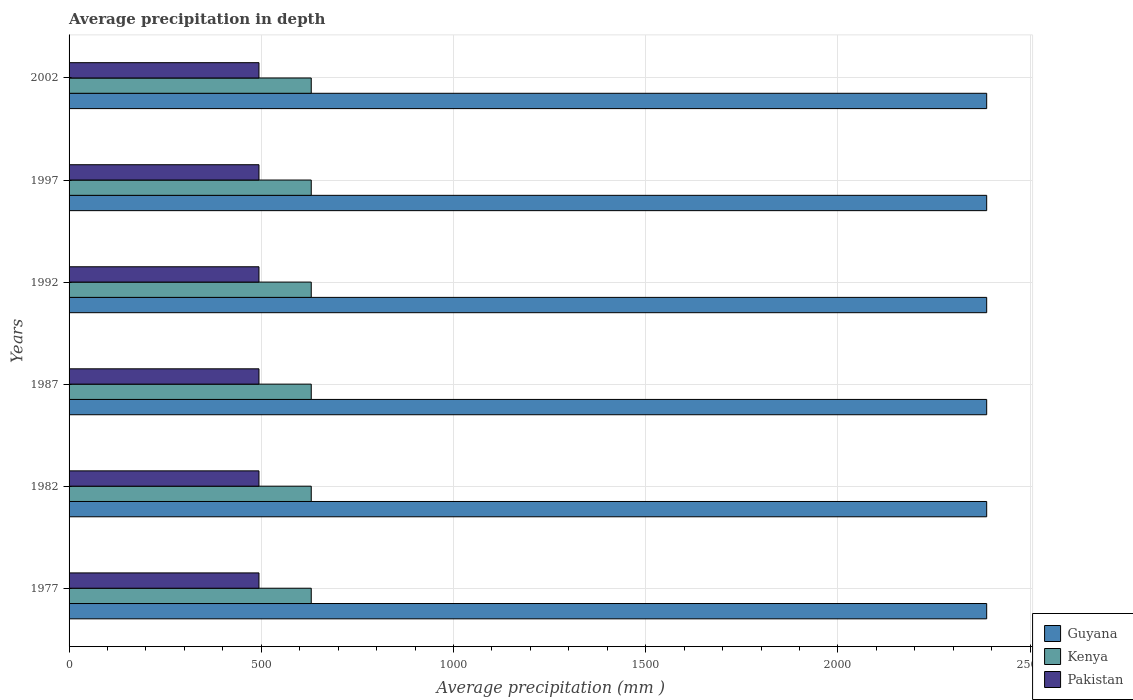How many different coloured bars are there?
Give a very brief answer. 3. What is the average precipitation in Kenya in 1992?
Your answer should be compact. 630. Across all years, what is the maximum average precipitation in Pakistan?
Ensure brevity in your answer.  494. Across all years, what is the minimum average precipitation in Guyana?
Offer a very short reply. 2387. In which year was the average precipitation in Kenya maximum?
Your answer should be compact. 1977. What is the total average precipitation in Guyana in the graph?
Provide a succinct answer. 1.43e+04. What is the difference between the average precipitation in Kenya in 1987 and the average precipitation in Guyana in 2002?
Make the answer very short. -1757. What is the average average precipitation in Kenya per year?
Your answer should be compact. 630. In the year 2002, what is the difference between the average precipitation in Kenya and average precipitation in Guyana?
Your answer should be compact. -1757. In how many years, is the average precipitation in Guyana greater than 1200 mm?
Keep it short and to the point. 6. Is the average precipitation in Kenya in 1987 less than that in 1997?
Your answer should be compact. No. Is the difference between the average precipitation in Kenya in 1982 and 1997 greater than the difference between the average precipitation in Guyana in 1982 and 1997?
Your answer should be very brief. No. Is the sum of the average precipitation in Kenya in 1977 and 2002 greater than the maximum average precipitation in Guyana across all years?
Provide a short and direct response. No. What does the 3rd bar from the bottom in 1997 represents?
Provide a succinct answer. Pakistan. What is the difference between two consecutive major ticks on the X-axis?
Make the answer very short. 500. Does the graph contain any zero values?
Give a very brief answer. No. Does the graph contain grids?
Offer a very short reply. Yes. Where does the legend appear in the graph?
Your answer should be very brief. Bottom right. How many legend labels are there?
Offer a terse response. 3. How are the legend labels stacked?
Give a very brief answer. Vertical. What is the title of the graph?
Your response must be concise. Average precipitation in depth. What is the label or title of the X-axis?
Provide a succinct answer. Average precipitation (mm ). What is the Average precipitation (mm ) of Guyana in 1977?
Ensure brevity in your answer.  2387. What is the Average precipitation (mm ) in Kenya in 1977?
Your answer should be compact. 630. What is the Average precipitation (mm ) in Pakistan in 1977?
Offer a terse response. 494. What is the Average precipitation (mm ) of Guyana in 1982?
Your answer should be very brief. 2387. What is the Average precipitation (mm ) in Kenya in 1982?
Offer a terse response. 630. What is the Average precipitation (mm ) of Pakistan in 1982?
Your answer should be very brief. 494. What is the Average precipitation (mm ) in Guyana in 1987?
Keep it short and to the point. 2387. What is the Average precipitation (mm ) in Kenya in 1987?
Give a very brief answer. 630. What is the Average precipitation (mm ) in Pakistan in 1987?
Your answer should be compact. 494. What is the Average precipitation (mm ) in Guyana in 1992?
Your answer should be compact. 2387. What is the Average precipitation (mm ) in Kenya in 1992?
Your response must be concise. 630. What is the Average precipitation (mm ) of Pakistan in 1992?
Give a very brief answer. 494. What is the Average precipitation (mm ) in Guyana in 1997?
Ensure brevity in your answer.  2387. What is the Average precipitation (mm ) in Kenya in 1997?
Your answer should be compact. 630. What is the Average precipitation (mm ) in Pakistan in 1997?
Your answer should be compact. 494. What is the Average precipitation (mm ) of Guyana in 2002?
Keep it short and to the point. 2387. What is the Average precipitation (mm ) of Kenya in 2002?
Your answer should be compact. 630. What is the Average precipitation (mm ) of Pakistan in 2002?
Give a very brief answer. 494. Across all years, what is the maximum Average precipitation (mm ) in Guyana?
Make the answer very short. 2387. Across all years, what is the maximum Average precipitation (mm ) in Kenya?
Provide a succinct answer. 630. Across all years, what is the maximum Average precipitation (mm ) in Pakistan?
Provide a short and direct response. 494. Across all years, what is the minimum Average precipitation (mm ) in Guyana?
Your response must be concise. 2387. Across all years, what is the minimum Average precipitation (mm ) of Kenya?
Your response must be concise. 630. Across all years, what is the minimum Average precipitation (mm ) in Pakistan?
Provide a succinct answer. 494. What is the total Average precipitation (mm ) in Guyana in the graph?
Make the answer very short. 1.43e+04. What is the total Average precipitation (mm ) of Kenya in the graph?
Your answer should be compact. 3780. What is the total Average precipitation (mm ) of Pakistan in the graph?
Your answer should be very brief. 2964. What is the difference between the Average precipitation (mm ) in Guyana in 1977 and that in 1982?
Offer a terse response. 0. What is the difference between the Average precipitation (mm ) in Kenya in 1977 and that in 1982?
Offer a terse response. 0. What is the difference between the Average precipitation (mm ) in Pakistan in 1977 and that in 1982?
Your response must be concise. 0. What is the difference between the Average precipitation (mm ) of Kenya in 1977 and that in 1987?
Your answer should be very brief. 0. What is the difference between the Average precipitation (mm ) of Guyana in 1977 and that in 1992?
Your response must be concise. 0. What is the difference between the Average precipitation (mm ) in Pakistan in 1977 and that in 1992?
Your answer should be very brief. 0. What is the difference between the Average precipitation (mm ) in Kenya in 1977 and that in 1997?
Your answer should be very brief. 0. What is the difference between the Average precipitation (mm ) in Pakistan in 1977 and that in 1997?
Offer a very short reply. 0. What is the difference between the Average precipitation (mm ) of Guyana in 1977 and that in 2002?
Offer a very short reply. 0. What is the difference between the Average precipitation (mm ) of Pakistan in 1977 and that in 2002?
Offer a terse response. 0. What is the difference between the Average precipitation (mm ) in Guyana in 1982 and that in 1987?
Make the answer very short. 0. What is the difference between the Average precipitation (mm ) in Pakistan in 1982 and that in 1987?
Ensure brevity in your answer.  0. What is the difference between the Average precipitation (mm ) of Pakistan in 1982 and that in 1992?
Provide a succinct answer. 0. What is the difference between the Average precipitation (mm ) of Pakistan in 1982 and that in 1997?
Offer a very short reply. 0. What is the difference between the Average precipitation (mm ) in Guyana in 1982 and that in 2002?
Keep it short and to the point. 0. What is the difference between the Average precipitation (mm ) of Kenya in 1982 and that in 2002?
Give a very brief answer. 0. What is the difference between the Average precipitation (mm ) of Guyana in 1987 and that in 1992?
Provide a short and direct response. 0. What is the difference between the Average precipitation (mm ) of Pakistan in 1987 and that in 1992?
Offer a terse response. 0. What is the difference between the Average precipitation (mm ) of Guyana in 1987 and that in 1997?
Keep it short and to the point. 0. What is the difference between the Average precipitation (mm ) in Kenya in 1987 and that in 1997?
Offer a terse response. 0. What is the difference between the Average precipitation (mm ) of Pakistan in 1987 and that in 1997?
Your answer should be very brief. 0. What is the difference between the Average precipitation (mm ) in Kenya in 1987 and that in 2002?
Make the answer very short. 0. What is the difference between the Average precipitation (mm ) in Guyana in 1992 and that in 1997?
Your answer should be compact. 0. What is the difference between the Average precipitation (mm ) in Kenya in 1997 and that in 2002?
Provide a succinct answer. 0. What is the difference between the Average precipitation (mm ) in Pakistan in 1997 and that in 2002?
Offer a terse response. 0. What is the difference between the Average precipitation (mm ) in Guyana in 1977 and the Average precipitation (mm ) in Kenya in 1982?
Give a very brief answer. 1757. What is the difference between the Average precipitation (mm ) of Guyana in 1977 and the Average precipitation (mm ) of Pakistan in 1982?
Provide a succinct answer. 1893. What is the difference between the Average precipitation (mm ) in Kenya in 1977 and the Average precipitation (mm ) in Pakistan in 1982?
Provide a succinct answer. 136. What is the difference between the Average precipitation (mm ) of Guyana in 1977 and the Average precipitation (mm ) of Kenya in 1987?
Offer a terse response. 1757. What is the difference between the Average precipitation (mm ) in Guyana in 1977 and the Average precipitation (mm ) in Pakistan in 1987?
Keep it short and to the point. 1893. What is the difference between the Average precipitation (mm ) of Kenya in 1977 and the Average precipitation (mm ) of Pakistan in 1987?
Your answer should be very brief. 136. What is the difference between the Average precipitation (mm ) of Guyana in 1977 and the Average precipitation (mm ) of Kenya in 1992?
Provide a succinct answer. 1757. What is the difference between the Average precipitation (mm ) of Guyana in 1977 and the Average precipitation (mm ) of Pakistan in 1992?
Offer a very short reply. 1893. What is the difference between the Average precipitation (mm ) of Kenya in 1977 and the Average precipitation (mm ) of Pakistan in 1992?
Offer a terse response. 136. What is the difference between the Average precipitation (mm ) in Guyana in 1977 and the Average precipitation (mm ) in Kenya in 1997?
Your response must be concise. 1757. What is the difference between the Average precipitation (mm ) in Guyana in 1977 and the Average precipitation (mm ) in Pakistan in 1997?
Offer a very short reply. 1893. What is the difference between the Average precipitation (mm ) of Kenya in 1977 and the Average precipitation (mm ) of Pakistan in 1997?
Ensure brevity in your answer.  136. What is the difference between the Average precipitation (mm ) of Guyana in 1977 and the Average precipitation (mm ) of Kenya in 2002?
Provide a short and direct response. 1757. What is the difference between the Average precipitation (mm ) in Guyana in 1977 and the Average precipitation (mm ) in Pakistan in 2002?
Provide a short and direct response. 1893. What is the difference between the Average precipitation (mm ) in Kenya in 1977 and the Average precipitation (mm ) in Pakistan in 2002?
Your response must be concise. 136. What is the difference between the Average precipitation (mm ) in Guyana in 1982 and the Average precipitation (mm ) in Kenya in 1987?
Keep it short and to the point. 1757. What is the difference between the Average precipitation (mm ) of Guyana in 1982 and the Average precipitation (mm ) of Pakistan in 1987?
Your answer should be compact. 1893. What is the difference between the Average precipitation (mm ) in Kenya in 1982 and the Average precipitation (mm ) in Pakistan in 1987?
Provide a short and direct response. 136. What is the difference between the Average precipitation (mm ) in Guyana in 1982 and the Average precipitation (mm ) in Kenya in 1992?
Your answer should be compact. 1757. What is the difference between the Average precipitation (mm ) of Guyana in 1982 and the Average precipitation (mm ) of Pakistan in 1992?
Provide a short and direct response. 1893. What is the difference between the Average precipitation (mm ) of Kenya in 1982 and the Average precipitation (mm ) of Pakistan in 1992?
Provide a succinct answer. 136. What is the difference between the Average precipitation (mm ) in Guyana in 1982 and the Average precipitation (mm ) in Kenya in 1997?
Keep it short and to the point. 1757. What is the difference between the Average precipitation (mm ) of Guyana in 1982 and the Average precipitation (mm ) of Pakistan in 1997?
Make the answer very short. 1893. What is the difference between the Average precipitation (mm ) in Kenya in 1982 and the Average precipitation (mm ) in Pakistan in 1997?
Your answer should be very brief. 136. What is the difference between the Average precipitation (mm ) of Guyana in 1982 and the Average precipitation (mm ) of Kenya in 2002?
Your answer should be very brief. 1757. What is the difference between the Average precipitation (mm ) of Guyana in 1982 and the Average precipitation (mm ) of Pakistan in 2002?
Provide a short and direct response. 1893. What is the difference between the Average precipitation (mm ) in Kenya in 1982 and the Average precipitation (mm ) in Pakistan in 2002?
Offer a terse response. 136. What is the difference between the Average precipitation (mm ) of Guyana in 1987 and the Average precipitation (mm ) of Kenya in 1992?
Provide a short and direct response. 1757. What is the difference between the Average precipitation (mm ) of Guyana in 1987 and the Average precipitation (mm ) of Pakistan in 1992?
Your response must be concise. 1893. What is the difference between the Average precipitation (mm ) of Kenya in 1987 and the Average precipitation (mm ) of Pakistan in 1992?
Make the answer very short. 136. What is the difference between the Average precipitation (mm ) in Guyana in 1987 and the Average precipitation (mm ) in Kenya in 1997?
Keep it short and to the point. 1757. What is the difference between the Average precipitation (mm ) of Guyana in 1987 and the Average precipitation (mm ) of Pakistan in 1997?
Offer a very short reply. 1893. What is the difference between the Average precipitation (mm ) in Kenya in 1987 and the Average precipitation (mm ) in Pakistan in 1997?
Ensure brevity in your answer.  136. What is the difference between the Average precipitation (mm ) in Guyana in 1987 and the Average precipitation (mm ) in Kenya in 2002?
Your response must be concise. 1757. What is the difference between the Average precipitation (mm ) in Guyana in 1987 and the Average precipitation (mm ) in Pakistan in 2002?
Ensure brevity in your answer.  1893. What is the difference between the Average precipitation (mm ) in Kenya in 1987 and the Average precipitation (mm ) in Pakistan in 2002?
Your answer should be compact. 136. What is the difference between the Average precipitation (mm ) in Guyana in 1992 and the Average precipitation (mm ) in Kenya in 1997?
Ensure brevity in your answer.  1757. What is the difference between the Average precipitation (mm ) in Guyana in 1992 and the Average precipitation (mm ) in Pakistan in 1997?
Give a very brief answer. 1893. What is the difference between the Average precipitation (mm ) of Kenya in 1992 and the Average precipitation (mm ) of Pakistan in 1997?
Give a very brief answer. 136. What is the difference between the Average precipitation (mm ) of Guyana in 1992 and the Average precipitation (mm ) of Kenya in 2002?
Ensure brevity in your answer.  1757. What is the difference between the Average precipitation (mm ) in Guyana in 1992 and the Average precipitation (mm ) in Pakistan in 2002?
Offer a very short reply. 1893. What is the difference between the Average precipitation (mm ) in Kenya in 1992 and the Average precipitation (mm ) in Pakistan in 2002?
Keep it short and to the point. 136. What is the difference between the Average precipitation (mm ) in Guyana in 1997 and the Average precipitation (mm ) in Kenya in 2002?
Offer a terse response. 1757. What is the difference between the Average precipitation (mm ) in Guyana in 1997 and the Average precipitation (mm ) in Pakistan in 2002?
Offer a terse response. 1893. What is the difference between the Average precipitation (mm ) in Kenya in 1997 and the Average precipitation (mm ) in Pakistan in 2002?
Your answer should be very brief. 136. What is the average Average precipitation (mm ) of Guyana per year?
Provide a succinct answer. 2387. What is the average Average precipitation (mm ) of Kenya per year?
Your answer should be compact. 630. What is the average Average precipitation (mm ) of Pakistan per year?
Give a very brief answer. 494. In the year 1977, what is the difference between the Average precipitation (mm ) of Guyana and Average precipitation (mm ) of Kenya?
Your answer should be very brief. 1757. In the year 1977, what is the difference between the Average precipitation (mm ) of Guyana and Average precipitation (mm ) of Pakistan?
Provide a short and direct response. 1893. In the year 1977, what is the difference between the Average precipitation (mm ) in Kenya and Average precipitation (mm ) in Pakistan?
Your answer should be compact. 136. In the year 1982, what is the difference between the Average precipitation (mm ) in Guyana and Average precipitation (mm ) in Kenya?
Ensure brevity in your answer.  1757. In the year 1982, what is the difference between the Average precipitation (mm ) of Guyana and Average precipitation (mm ) of Pakistan?
Offer a very short reply. 1893. In the year 1982, what is the difference between the Average precipitation (mm ) of Kenya and Average precipitation (mm ) of Pakistan?
Provide a succinct answer. 136. In the year 1987, what is the difference between the Average precipitation (mm ) in Guyana and Average precipitation (mm ) in Kenya?
Your answer should be very brief. 1757. In the year 1987, what is the difference between the Average precipitation (mm ) of Guyana and Average precipitation (mm ) of Pakistan?
Provide a succinct answer. 1893. In the year 1987, what is the difference between the Average precipitation (mm ) in Kenya and Average precipitation (mm ) in Pakistan?
Your response must be concise. 136. In the year 1992, what is the difference between the Average precipitation (mm ) in Guyana and Average precipitation (mm ) in Kenya?
Give a very brief answer. 1757. In the year 1992, what is the difference between the Average precipitation (mm ) of Guyana and Average precipitation (mm ) of Pakistan?
Ensure brevity in your answer.  1893. In the year 1992, what is the difference between the Average precipitation (mm ) of Kenya and Average precipitation (mm ) of Pakistan?
Give a very brief answer. 136. In the year 1997, what is the difference between the Average precipitation (mm ) of Guyana and Average precipitation (mm ) of Kenya?
Your answer should be compact. 1757. In the year 1997, what is the difference between the Average precipitation (mm ) in Guyana and Average precipitation (mm ) in Pakistan?
Keep it short and to the point. 1893. In the year 1997, what is the difference between the Average precipitation (mm ) of Kenya and Average precipitation (mm ) of Pakistan?
Your answer should be compact. 136. In the year 2002, what is the difference between the Average precipitation (mm ) in Guyana and Average precipitation (mm ) in Kenya?
Keep it short and to the point. 1757. In the year 2002, what is the difference between the Average precipitation (mm ) of Guyana and Average precipitation (mm ) of Pakistan?
Provide a short and direct response. 1893. In the year 2002, what is the difference between the Average precipitation (mm ) in Kenya and Average precipitation (mm ) in Pakistan?
Provide a short and direct response. 136. What is the ratio of the Average precipitation (mm ) in Pakistan in 1977 to that in 1982?
Your answer should be compact. 1. What is the ratio of the Average precipitation (mm ) in Kenya in 1977 to that in 1987?
Ensure brevity in your answer.  1. What is the ratio of the Average precipitation (mm ) in Kenya in 1977 to that in 1992?
Your answer should be very brief. 1. What is the ratio of the Average precipitation (mm ) in Pakistan in 1977 to that in 1992?
Make the answer very short. 1. What is the ratio of the Average precipitation (mm ) of Kenya in 1977 to that in 1997?
Ensure brevity in your answer.  1. What is the ratio of the Average precipitation (mm ) of Guyana in 1977 to that in 2002?
Your response must be concise. 1. What is the ratio of the Average precipitation (mm ) in Kenya in 1977 to that in 2002?
Keep it short and to the point. 1. What is the ratio of the Average precipitation (mm ) of Pakistan in 1977 to that in 2002?
Your answer should be compact. 1. What is the ratio of the Average precipitation (mm ) of Pakistan in 1982 to that in 1987?
Give a very brief answer. 1. What is the ratio of the Average precipitation (mm ) in Guyana in 1982 to that in 1997?
Provide a short and direct response. 1. What is the ratio of the Average precipitation (mm ) in Pakistan in 1982 to that in 1997?
Offer a terse response. 1. What is the ratio of the Average precipitation (mm ) of Guyana in 1982 to that in 2002?
Your answer should be very brief. 1. What is the ratio of the Average precipitation (mm ) of Kenya in 1982 to that in 2002?
Make the answer very short. 1. What is the ratio of the Average precipitation (mm ) in Pakistan in 1982 to that in 2002?
Ensure brevity in your answer.  1. What is the ratio of the Average precipitation (mm ) in Guyana in 1987 to that in 1992?
Offer a terse response. 1. What is the ratio of the Average precipitation (mm ) in Kenya in 1987 to that in 1997?
Offer a terse response. 1. What is the ratio of the Average precipitation (mm ) of Pakistan in 1987 to that in 1997?
Give a very brief answer. 1. What is the ratio of the Average precipitation (mm ) in Kenya in 1987 to that in 2002?
Offer a very short reply. 1. What is the ratio of the Average precipitation (mm ) in Guyana in 1992 to that in 2002?
Your answer should be compact. 1. What is the ratio of the Average precipitation (mm ) in Kenya in 1992 to that in 2002?
Ensure brevity in your answer.  1. What is the ratio of the Average precipitation (mm ) in Guyana in 1997 to that in 2002?
Make the answer very short. 1. What is the difference between the highest and the second highest Average precipitation (mm ) of Guyana?
Your answer should be very brief. 0. What is the difference between the highest and the second highest Average precipitation (mm ) in Pakistan?
Your response must be concise. 0. What is the difference between the highest and the lowest Average precipitation (mm ) of Guyana?
Ensure brevity in your answer.  0. What is the difference between the highest and the lowest Average precipitation (mm ) of Pakistan?
Make the answer very short. 0. 